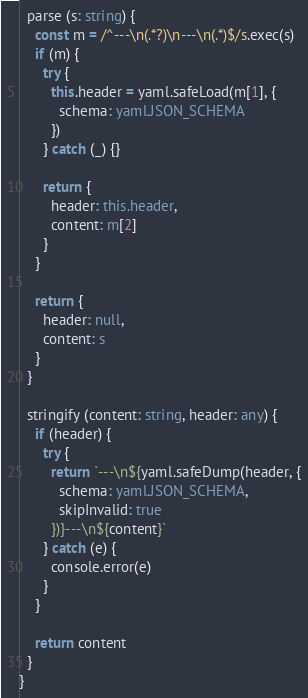<code> <loc_0><loc_0><loc_500><loc_500><_TypeScript_>
  parse (s: string) {
    const m = /^---\n(.*?)\n---\n(.*)$/s.exec(s)
    if (m) {
      try {
        this.header = yaml.safeLoad(m[1], {
          schema: yaml.JSON_SCHEMA
        })
      } catch (_) {}

      return {
        header: this.header,
        content: m[2]
      }
    }

    return {
      header: null,
      content: s
    }
  }

  stringify (content: string, header: any) {
    if (header) {
      try {
        return `---\n${yaml.safeDump(header, {
          schema: yaml.JSON_SCHEMA,
          skipInvalid: true
        })}---\n${content}`
      } catch (e) {
        console.error(e)
      }
    }

    return content
  }
}
</code> 